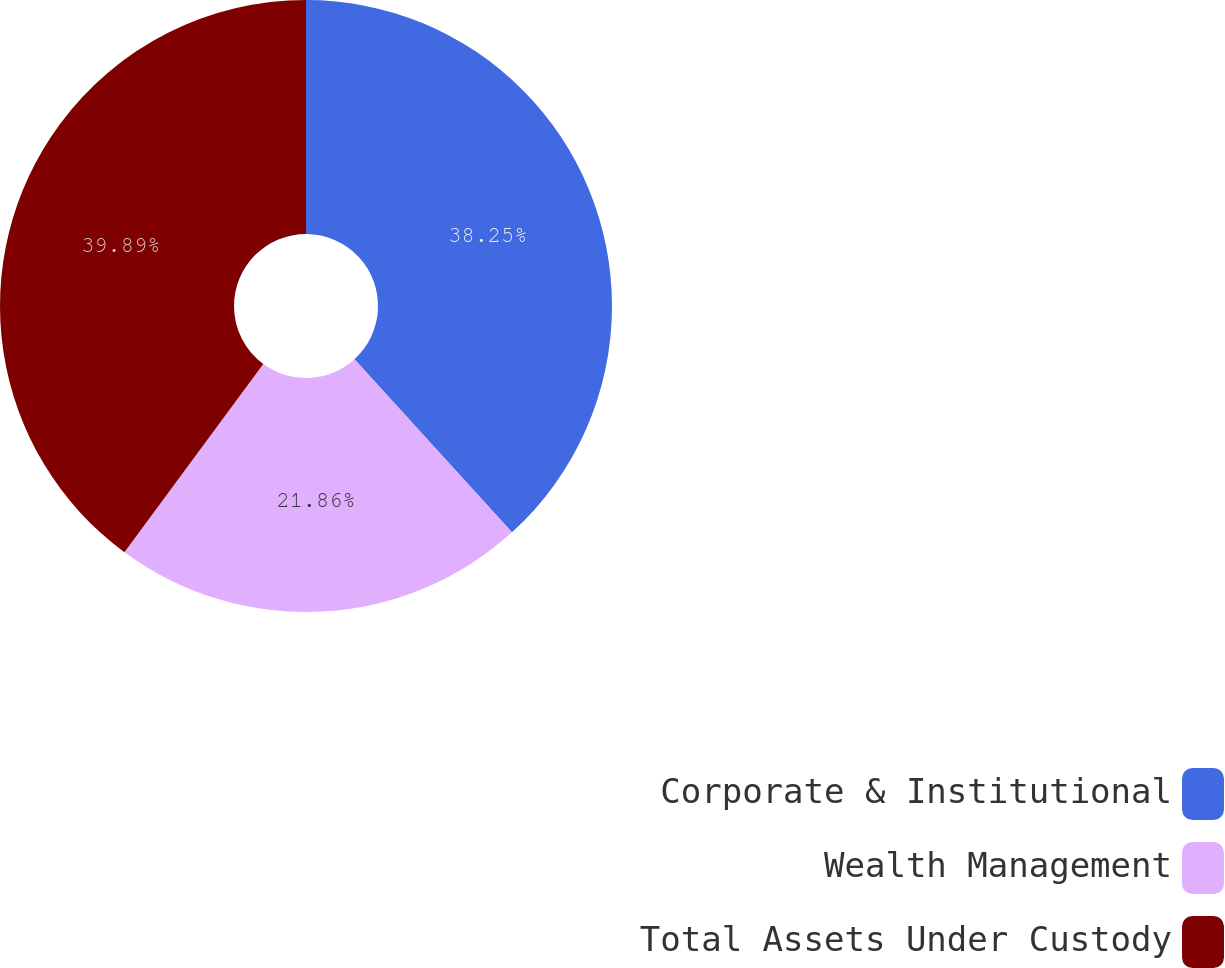Convert chart. <chart><loc_0><loc_0><loc_500><loc_500><pie_chart><fcel>Corporate & Institutional<fcel>Wealth Management<fcel>Total Assets Under Custody<nl><fcel>38.25%<fcel>21.86%<fcel>39.89%<nl></chart> 